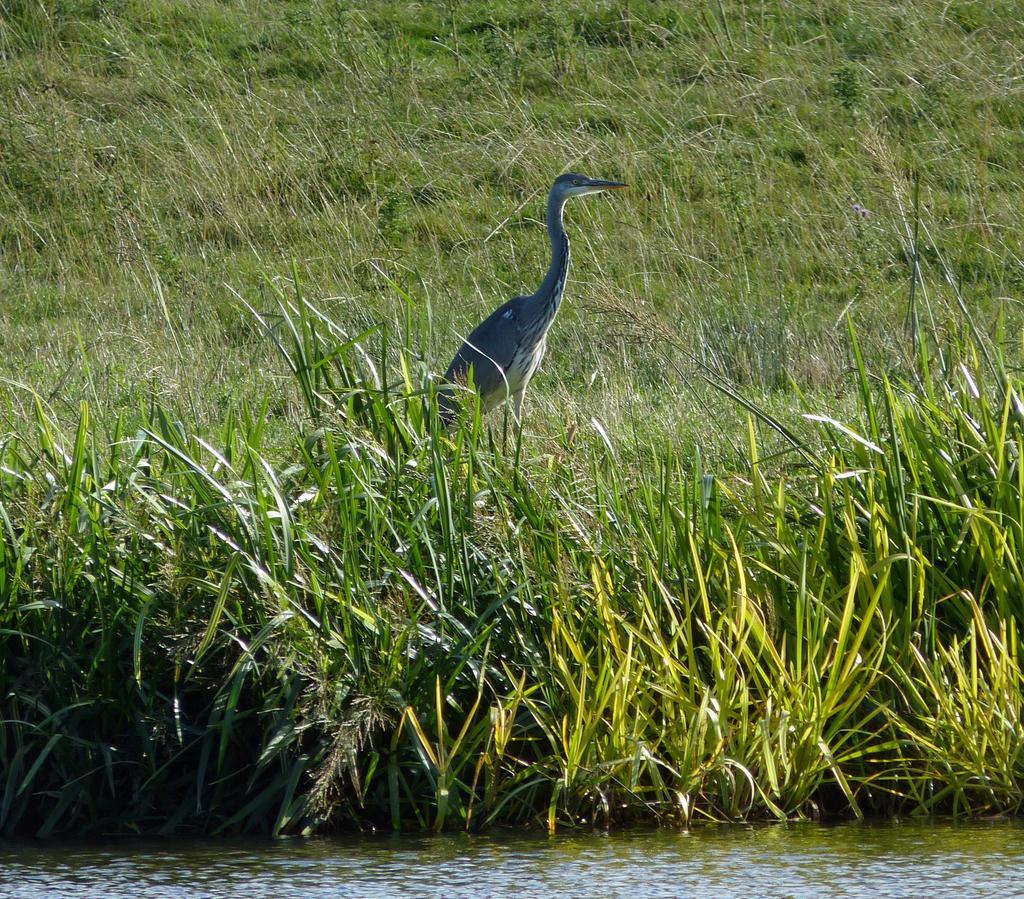Describe this image in one or two sentences. In this picture there is a crane in the center of the image and there is water at the bottom side of the image and there is grassland at the top side of the image. 